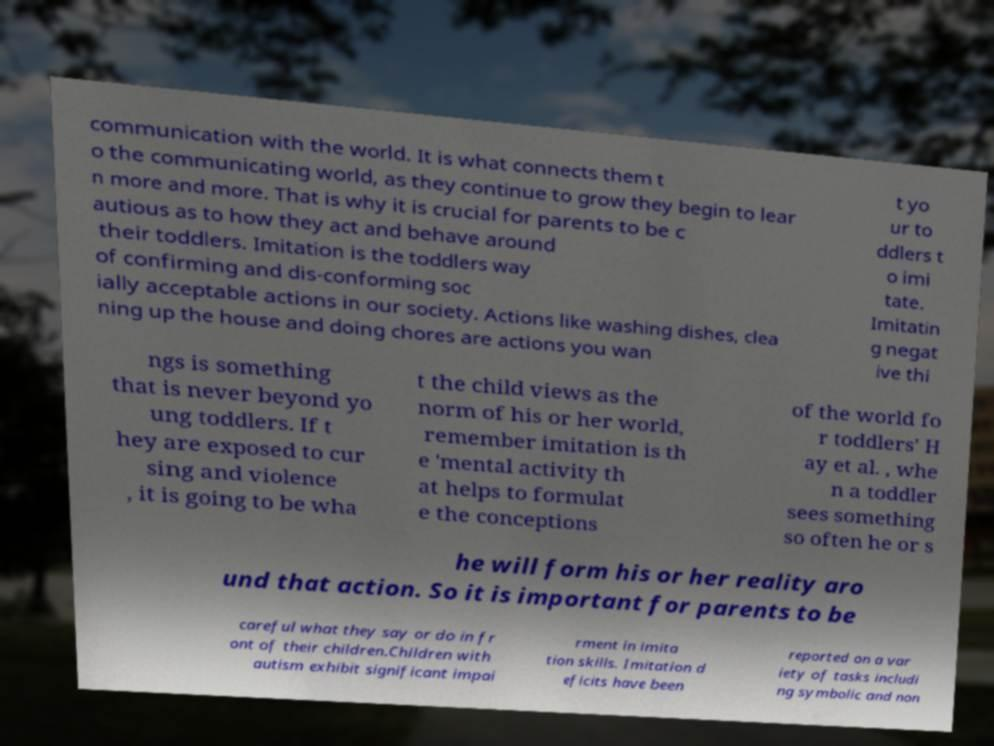Can you accurately transcribe the text from the provided image for me? communication with the world. It is what connects them t o the communicating world, as they continue to grow they begin to lear n more and more. That is why it is crucial for parents to be c autious as to how they act and behave around their toddlers. Imitation is the toddlers way of confirming and dis-conforming soc ially acceptable actions in our society. Actions like washing dishes, clea ning up the house and doing chores are actions you wan t yo ur to ddlers t o imi tate. Imitatin g negat ive thi ngs is something that is never beyond yo ung toddlers. If t hey are exposed to cur sing and violence , it is going to be wha t the child views as the norm of his or her world, remember imitation is th e 'mental activity th at helps to formulat e the conceptions of the world fo r toddlers' H ay et al. , whe n a toddler sees something so often he or s he will form his or her reality aro und that action. So it is important for parents to be careful what they say or do in fr ont of their children.Children with autism exhibit significant impai rment in imita tion skills. Imitation d eficits have been reported on a var iety of tasks includi ng symbolic and non 